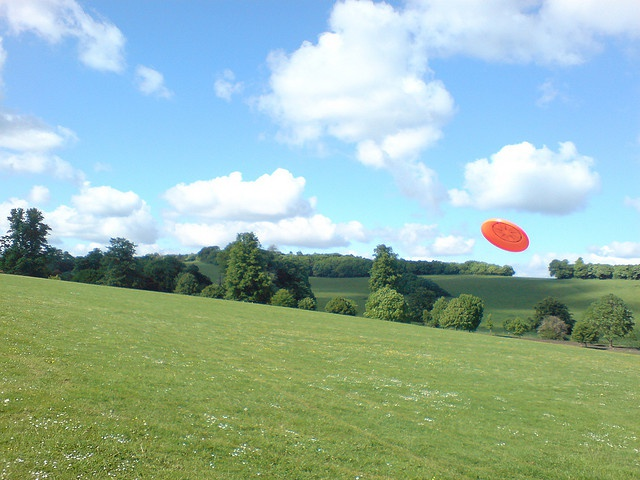Describe the objects in this image and their specific colors. I can see a frisbee in lavender, salmon, and violet tones in this image. 